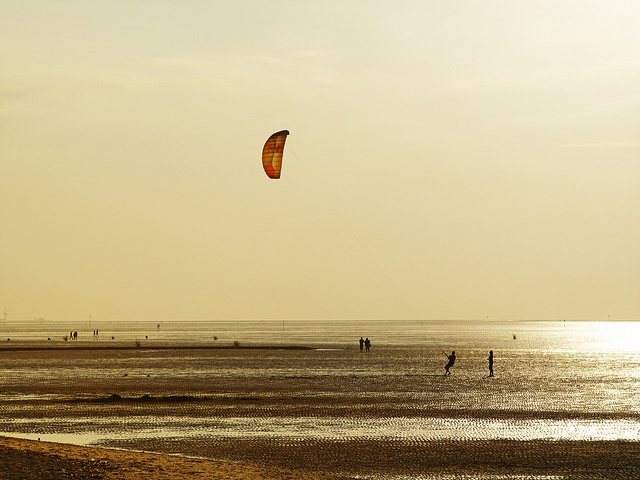Describe the objects in this image and their specific colors. I can see kite in beige, brown, maroon, and black tones, people in beige, black, olive, and maroon tones, people in beige, black, and tan tones, people in beige, tan, and olive tones, and people in beige, tan, maroon, and olive tones in this image. 